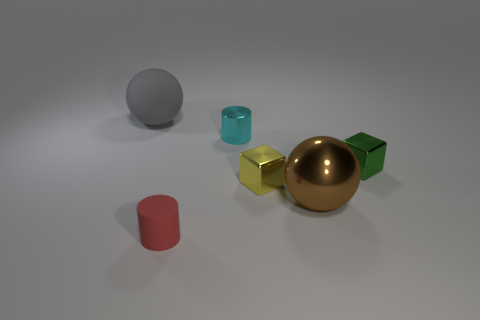Are there any tiny rubber cylinders behind the metal cylinder?
Give a very brief answer. No. There is another cylinder that is the same size as the shiny cylinder; what is its color?
Offer a very short reply. Red. How many objects are large objects that are on the left side of the big brown thing or large yellow things?
Offer a very short reply. 1. There is a thing that is both behind the green cube and in front of the gray matte object; what is its size?
Offer a terse response. Small. What number of other objects are the same size as the gray rubber ball?
Your answer should be very brief. 1. The ball that is left of the red matte thing in front of the large gray ball behind the tiny yellow shiny object is what color?
Your response must be concise. Gray. What shape is the thing that is both left of the cyan object and behind the red cylinder?
Your answer should be compact. Sphere. How many other things are the same shape as the big gray matte object?
Offer a terse response. 1. The small thing left of the small metallic cylinder that is in front of the big ball that is behind the green object is what shape?
Provide a short and direct response. Cylinder. How many objects are purple metallic blocks or large balls behind the cyan metal thing?
Offer a very short reply. 1. 